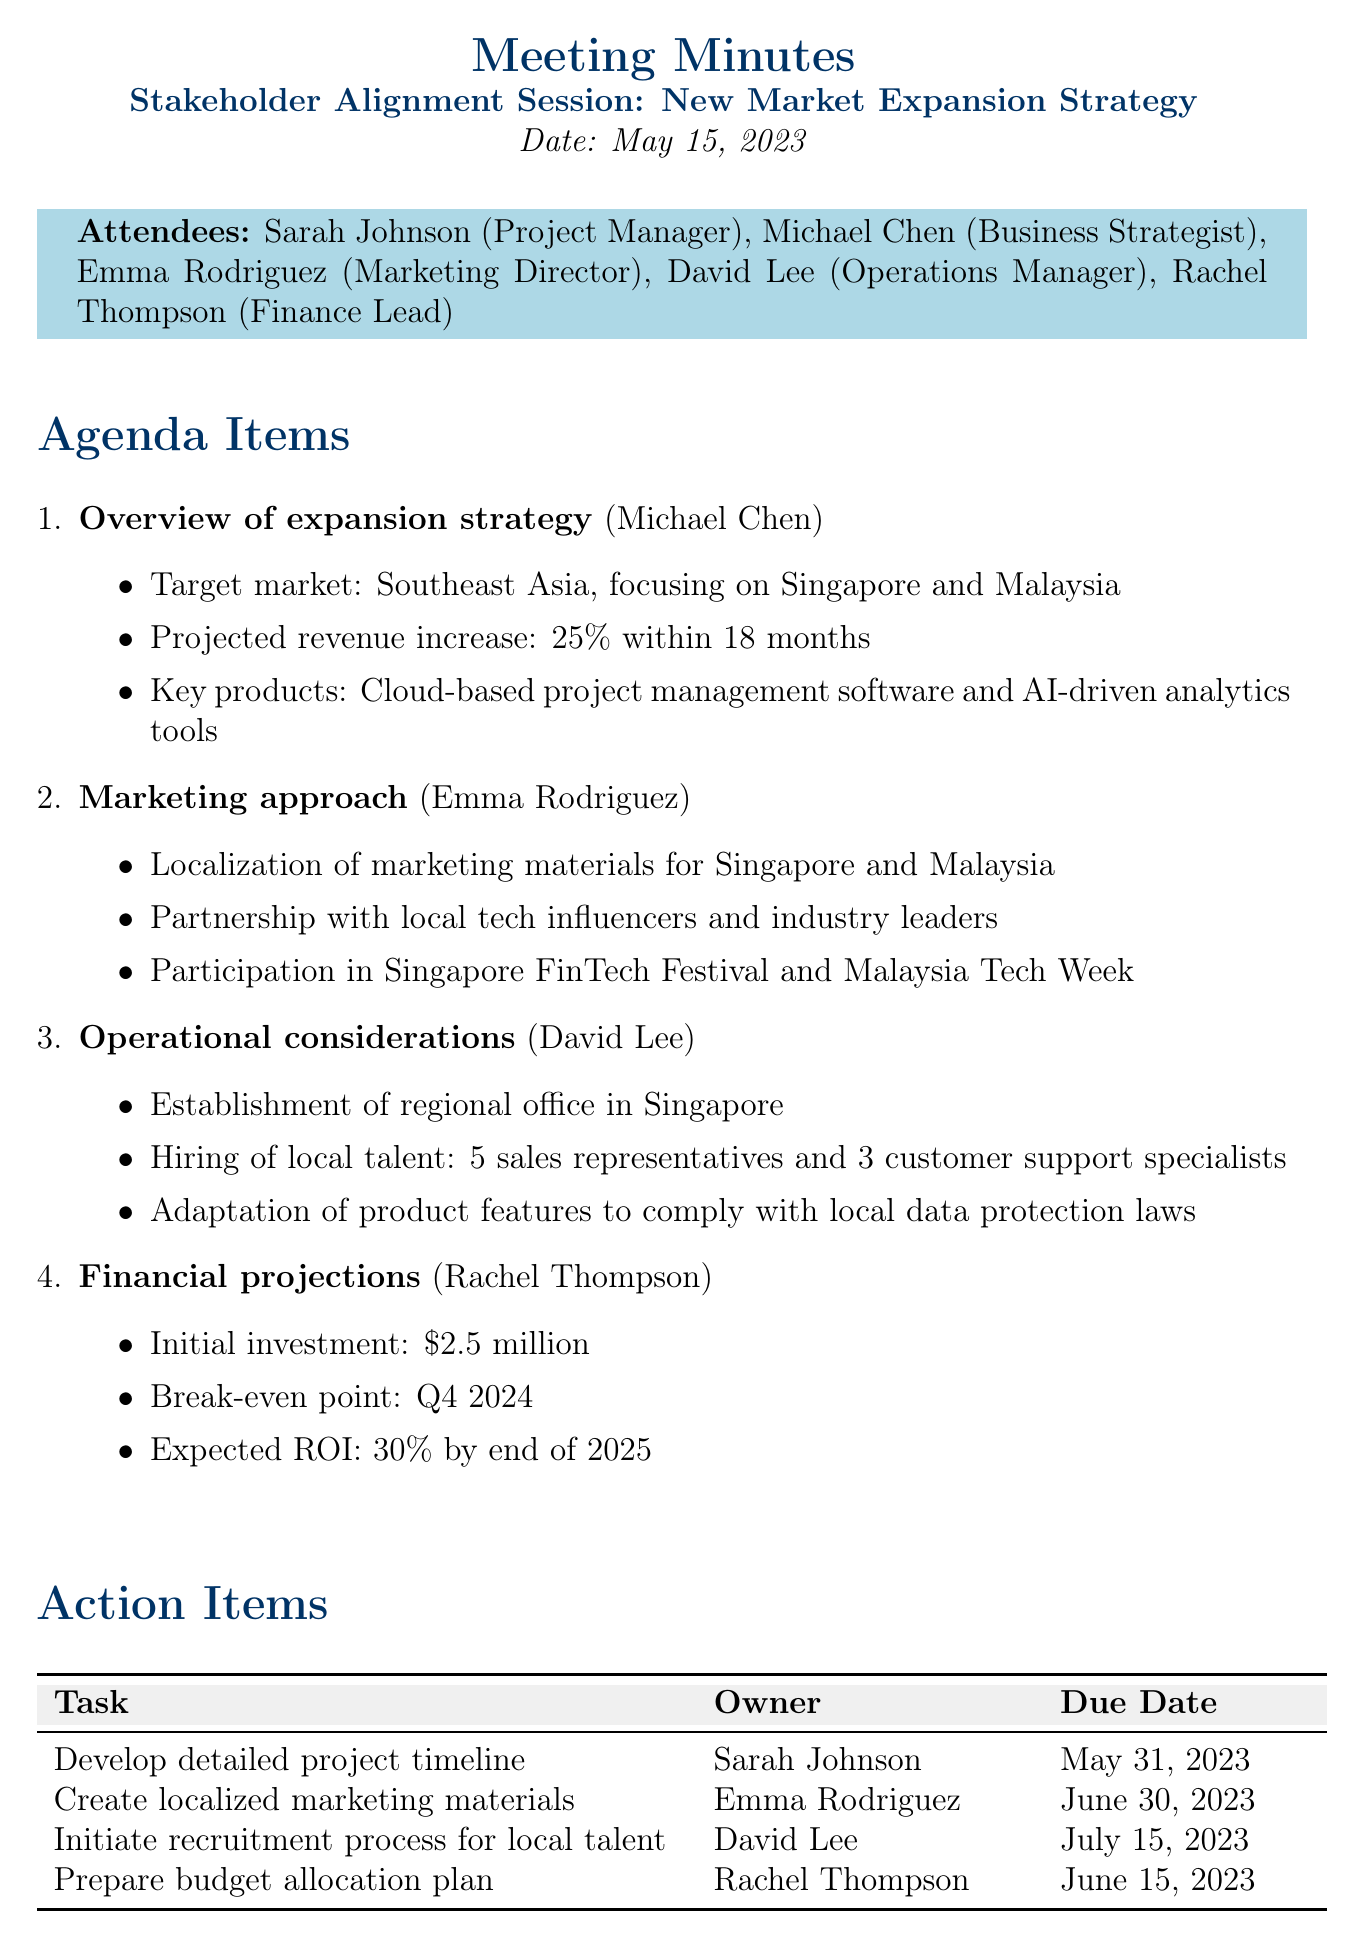what is the date of the meeting? The date of the meeting is stated at the beginning of the document, which is May 15, 2023.
Answer: May 15, 2023 who is responsible for creating localized marketing materials? The action item states that Emma Rodriguez is the owner for creating localized marketing materials.
Answer: Emma Rodriguez what is the target market for the expansion strategy? The target market is mentioned in the overview of the expansion strategy, focusing on Southeast Asia, specifically Singapore and Malaysia.
Answer: Southeast Asia, focusing on Singapore and Malaysia what is the expected ROI by the end of 2025? The financial projections section mentions the expected ROI of 30% by the end of 2025.
Answer: 30% when is the follow-up meeting scheduled? The next steps section specifically states that the follow-up meeting is scheduled for June 15, 2023.
Answer: June 15, 2023 how much is the initial investment required for the project? The financial projections specify that the initial investment required is $2.5 million.
Answer: $2.5 million how many sales representatives are to be hired? The operational considerations detail that 5 sales representatives are to be hired.
Answer: 5 who presented the overview of the expansion strategy? The agenda item for the overview states that Michael Chen presented this topic.
Answer: Michael Chen what is the due date for preparing the budget allocation plan? The action items indicate that Rachel Thompson is responsible for the budget allocation plan due by June 15, 2023.
Answer: June 15, 2023 